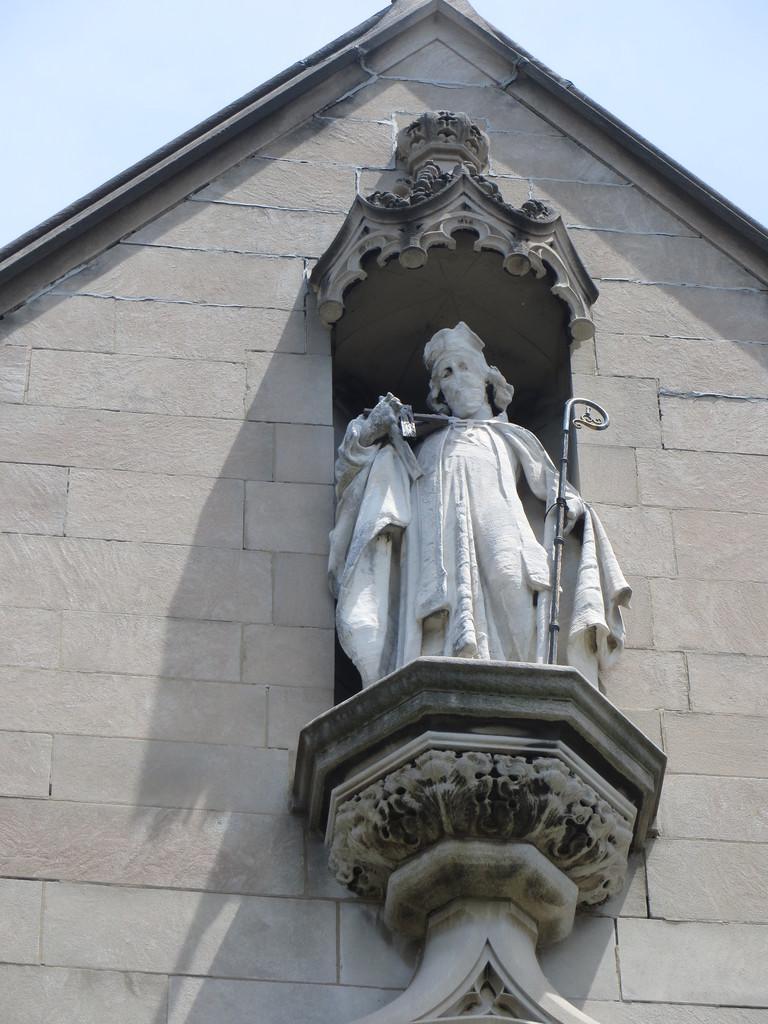Can you describe this image briefly? In the picture we can see a historical building wall with a sculpture to it of a man holding a stick and in the background we can see a sky. 